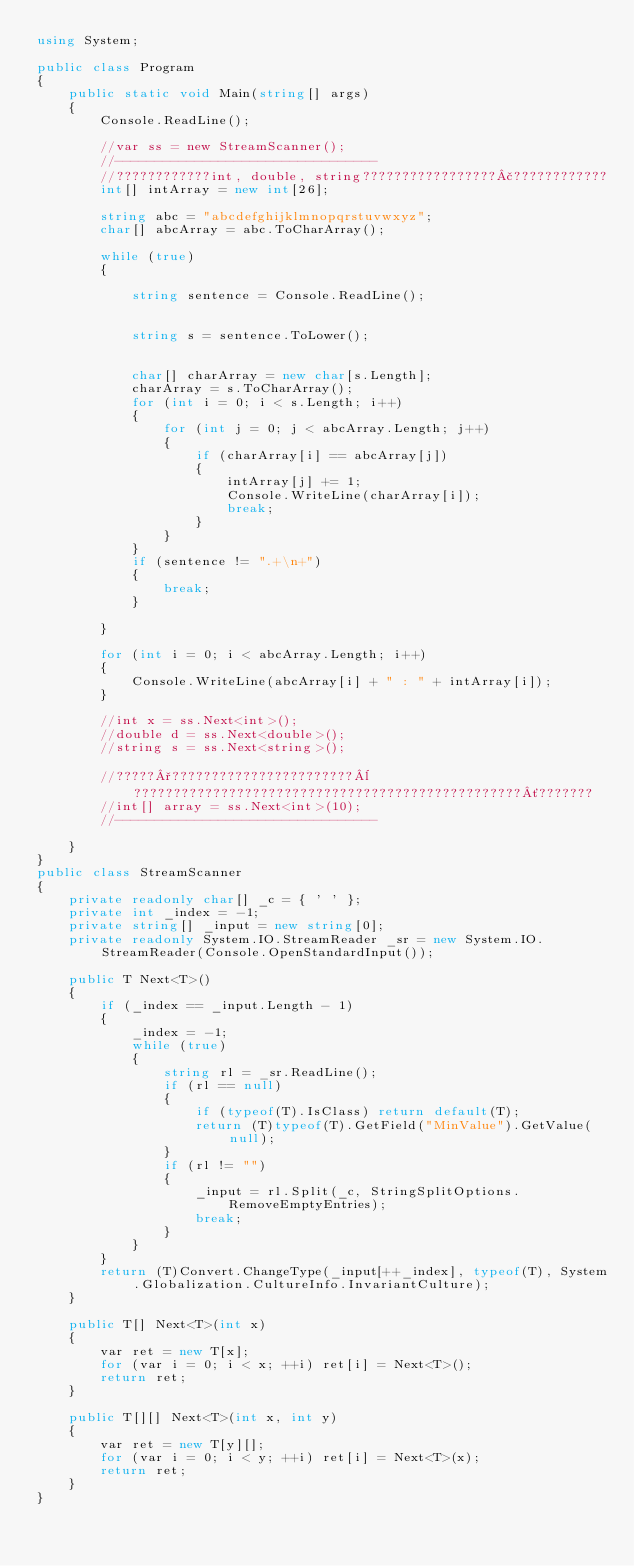<code> <loc_0><loc_0><loc_500><loc_500><_C#_>using System;

public class Program
{
	public static void Main(string[] args)
	{
		Console.ReadLine();

		//var ss = new StreamScanner();
		//---------------------------------
		//????????????int, double, string?????????????????£????????????
		int[] intArray = new int[26];

		string abc = "abcdefghijklmnopqrstuvwxyz";
		char[] abcArray = abc.ToCharArray();

		while (true) 
		{
			
			string sentence = Console.ReadLine();


			string s = sentence.ToLower();


			char[] charArray = new char[s.Length];
			charArray = s.ToCharArray();
			for (int i = 0; i < s.Length; i++)
			{
				for (int j = 0; j < abcArray.Length; j++)
				{
					if (charArray[i] == abcArray[j])
					{
						intArray[j] += 1;
						Console.WriteLine(charArray[i]);
						break;
					}
				}
			}
			if (sentence != ".+\n+")
			{
				break;
			}

		}

		for (int i = 0; i < abcArray.Length; i++)
		{
			Console.WriteLine(abcArray[i] + " : " + intArray[i]);
		}

		//int x = ss.Next<int>();
		//double d = ss.Next<double>();
		//string s = ss.Next<string>();

		//?????°???????????????????????¨?????????????????????????????????????????????????´???????
		//int[] array = ss.Next<int>(10);
		//---------------------------------

	}
}
public class StreamScanner
{
	private readonly char[] _c = { ' ' };
	private int _index = -1;
	private string[] _input = new string[0];
	private readonly System.IO.StreamReader _sr = new System.IO.StreamReader(Console.OpenStandardInput());

	public T Next<T>()
	{
		if (_index == _input.Length - 1)
		{
			_index = -1;
			while (true)
			{
				string rl = _sr.ReadLine();
				if (rl == null)
				{
					if (typeof(T).IsClass) return default(T);
					return (T)typeof(T).GetField("MinValue").GetValue(null);
				}
				if (rl != "")
				{
					_input = rl.Split(_c, StringSplitOptions.RemoveEmptyEntries);
					break;
				}
			}
		}
		return (T)Convert.ChangeType(_input[++_index], typeof(T), System.Globalization.CultureInfo.InvariantCulture);
	}

	public T[] Next<T>(int x)
	{
		var ret = new T[x];
		for (var i = 0; i < x; ++i) ret[i] = Next<T>();
		return ret;
	}

	public T[][] Next<T>(int x, int y)
	{
		var ret = new T[y][];
		for (var i = 0; i < y; ++i) ret[i] = Next<T>(x);
		return ret;
	}
}</code> 